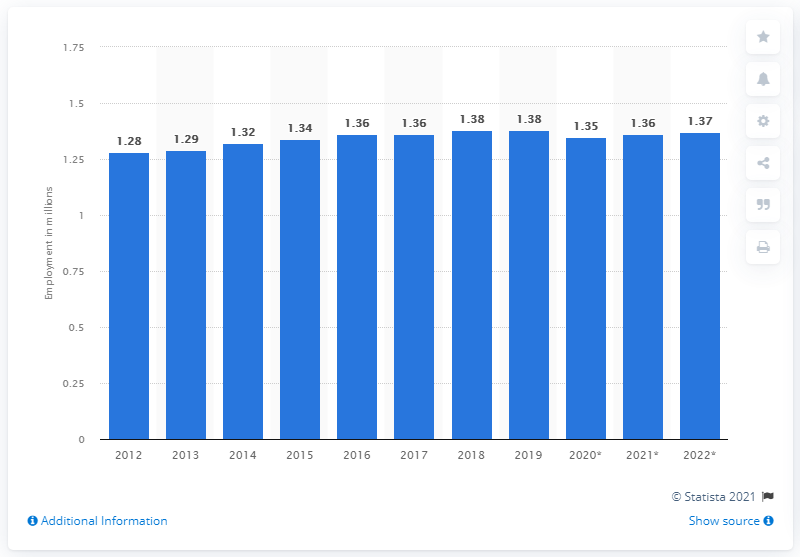Identify some key points in this picture. In 2019, there were approximately 1.37 million people employed in Lithuania. 